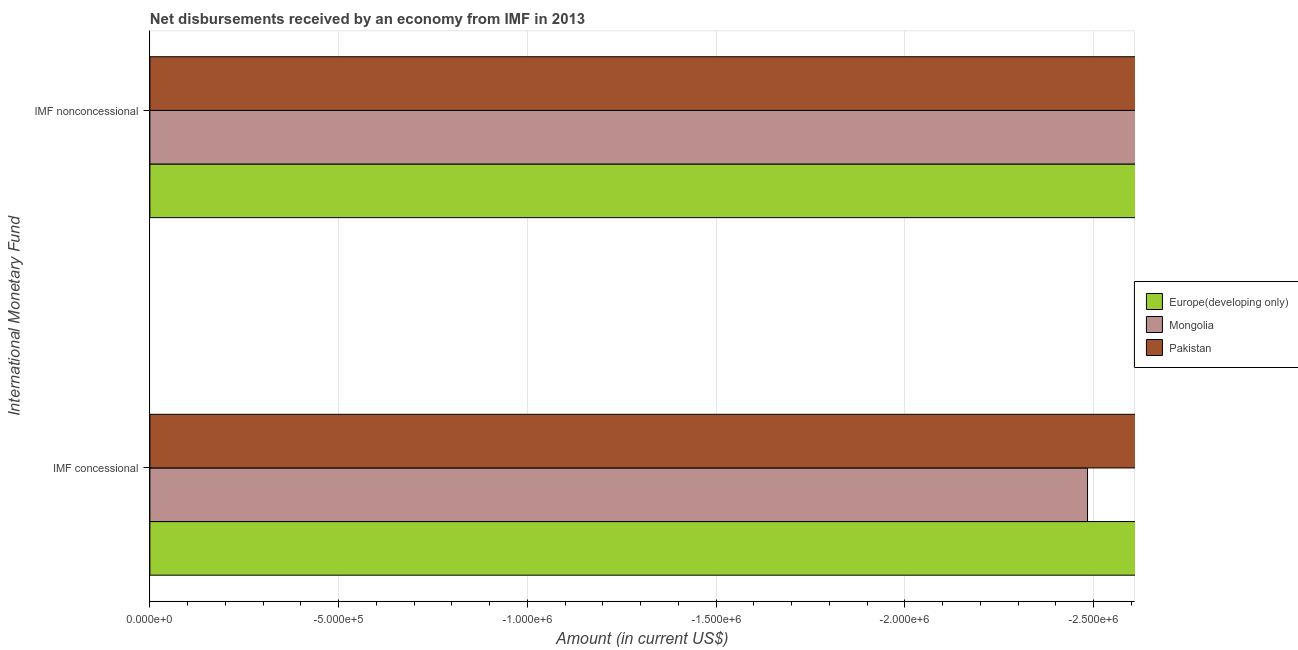How many different coloured bars are there?
Your response must be concise. 0. Are the number of bars per tick equal to the number of legend labels?
Provide a succinct answer. No. How many bars are there on the 2nd tick from the top?
Provide a short and direct response. 0. How many bars are there on the 1st tick from the bottom?
Give a very brief answer. 0. What is the label of the 1st group of bars from the top?
Your response must be concise. IMF nonconcessional. Across all countries, what is the minimum net concessional disbursements from imf?
Give a very brief answer. 0. What is the difference between the net concessional disbursements from imf in Pakistan and the net non concessional disbursements from imf in Europe(developing only)?
Ensure brevity in your answer.  0. What is the average net concessional disbursements from imf per country?
Your response must be concise. 0. How many countries are there in the graph?
Your response must be concise. 3. Are the values on the major ticks of X-axis written in scientific E-notation?
Make the answer very short. Yes. How many legend labels are there?
Give a very brief answer. 3. What is the title of the graph?
Make the answer very short. Net disbursements received by an economy from IMF in 2013. What is the label or title of the Y-axis?
Ensure brevity in your answer.  International Monetary Fund. What is the Amount (in current US$) in Mongolia in IMF concessional?
Your response must be concise. 0. What is the Amount (in current US$) in Pakistan in IMF concessional?
Keep it short and to the point. 0. What is the Amount (in current US$) in Pakistan in IMF nonconcessional?
Your response must be concise. 0. What is the total Amount (in current US$) of Europe(developing only) in the graph?
Ensure brevity in your answer.  0. What is the average Amount (in current US$) in Mongolia per International Monetary Fund?
Offer a terse response. 0. 